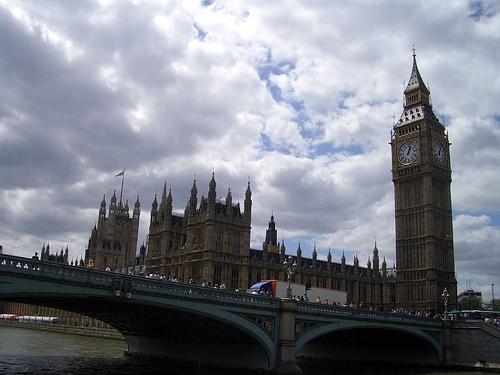Where is this?
Give a very brief answer. London. How many clock faces are there?
Concise answer only. 2. What time does the clock have?
Answer briefly. 1:05. 